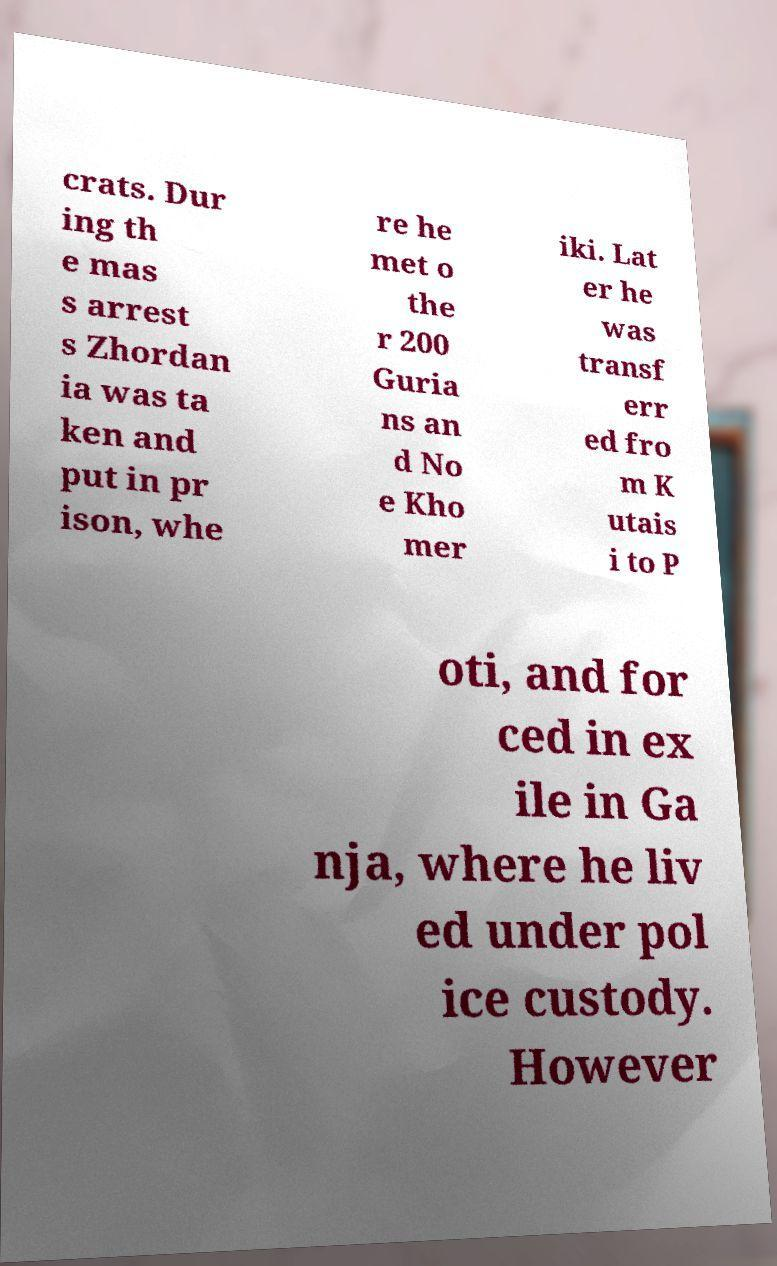There's text embedded in this image that I need extracted. Can you transcribe it verbatim? crats. Dur ing th e mas s arrest s Zhordan ia was ta ken and put in pr ison, whe re he met o the r 200 Guria ns an d No e Kho mer iki. Lat er he was transf err ed fro m K utais i to P oti, and for ced in ex ile in Ga nja, where he liv ed under pol ice custody. However 